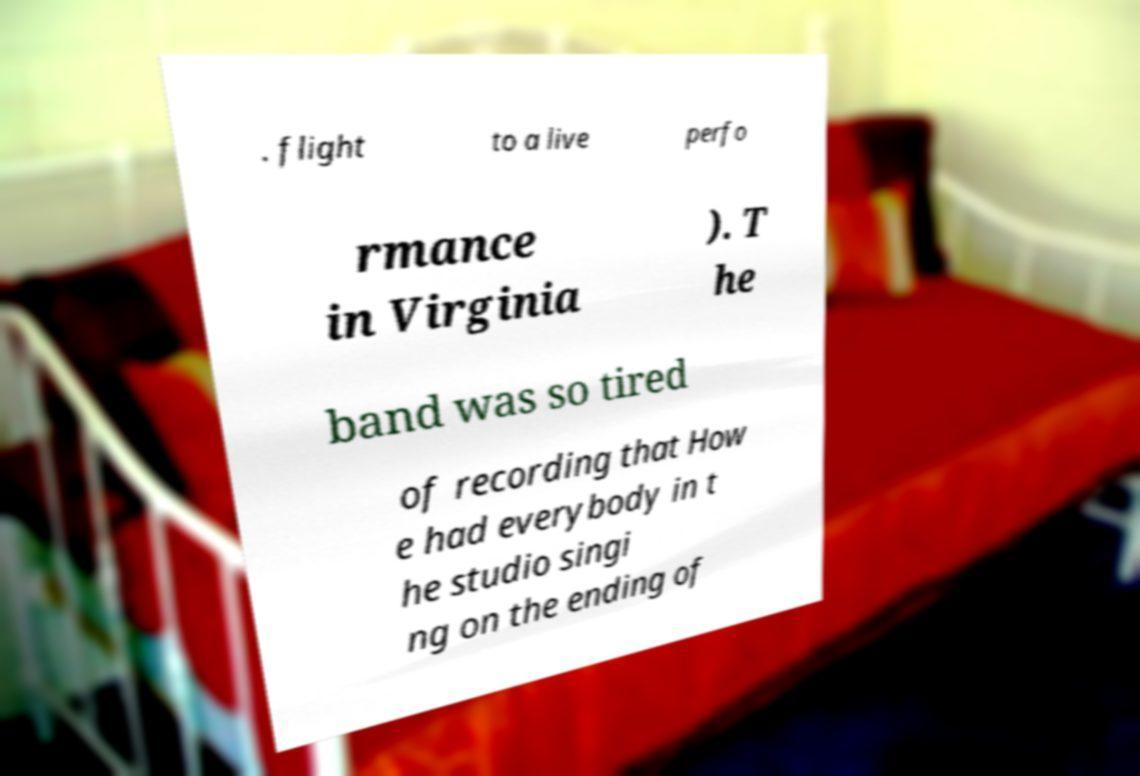Can you accurately transcribe the text from the provided image for me? . flight to a live perfo rmance in Virginia ). T he band was so tired of recording that How e had everybody in t he studio singi ng on the ending of 